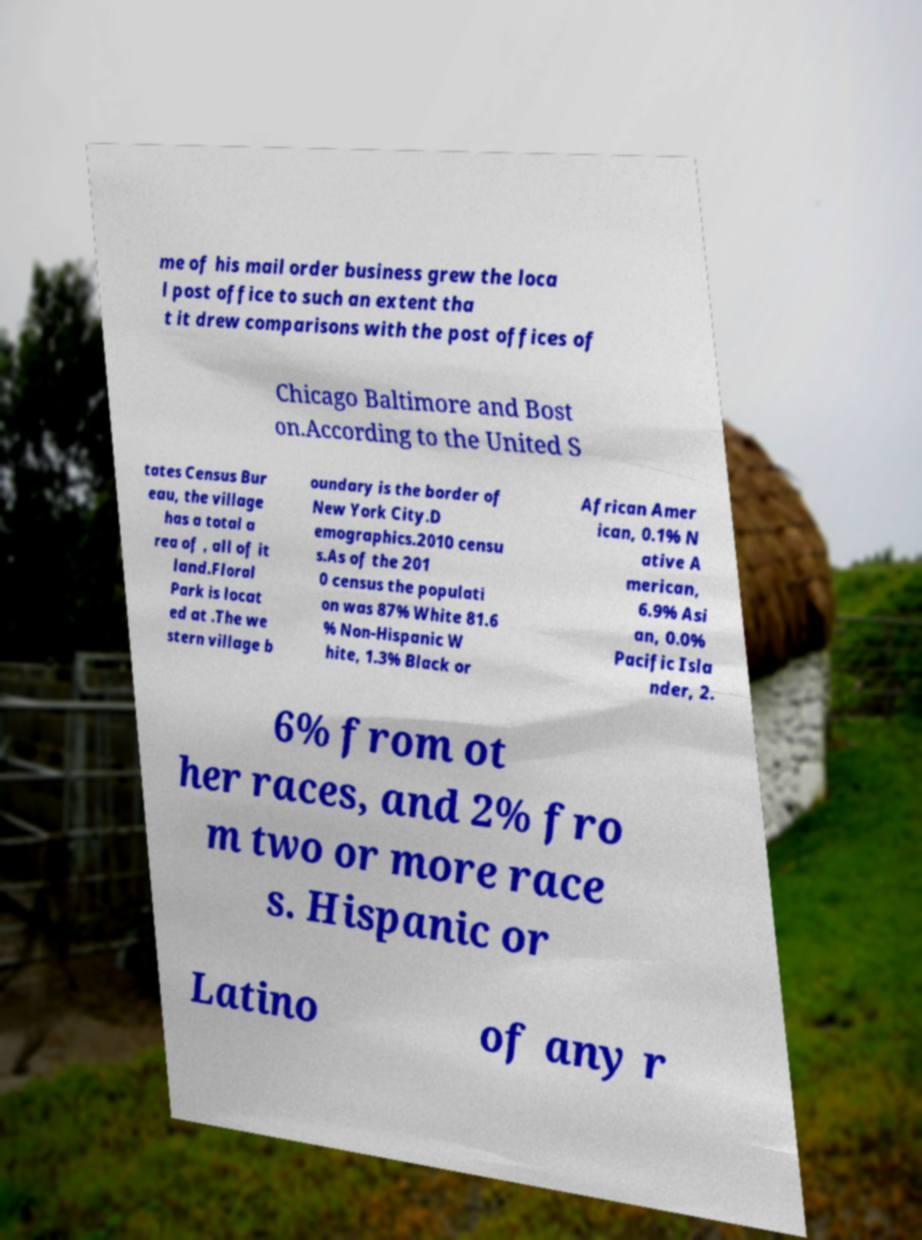For documentation purposes, I need the text within this image transcribed. Could you provide that? me of his mail order business grew the loca l post office to such an extent tha t it drew comparisons with the post offices of Chicago Baltimore and Bost on.According to the United S tates Census Bur eau, the village has a total a rea of , all of it land.Floral Park is locat ed at .The we stern village b oundary is the border of New York City.D emographics.2010 censu s.As of the 201 0 census the populati on was 87% White 81.6 % Non-Hispanic W hite, 1.3% Black or African Amer ican, 0.1% N ative A merican, 6.9% Asi an, 0.0% Pacific Isla nder, 2. 6% from ot her races, and 2% fro m two or more race s. Hispanic or Latino of any r 